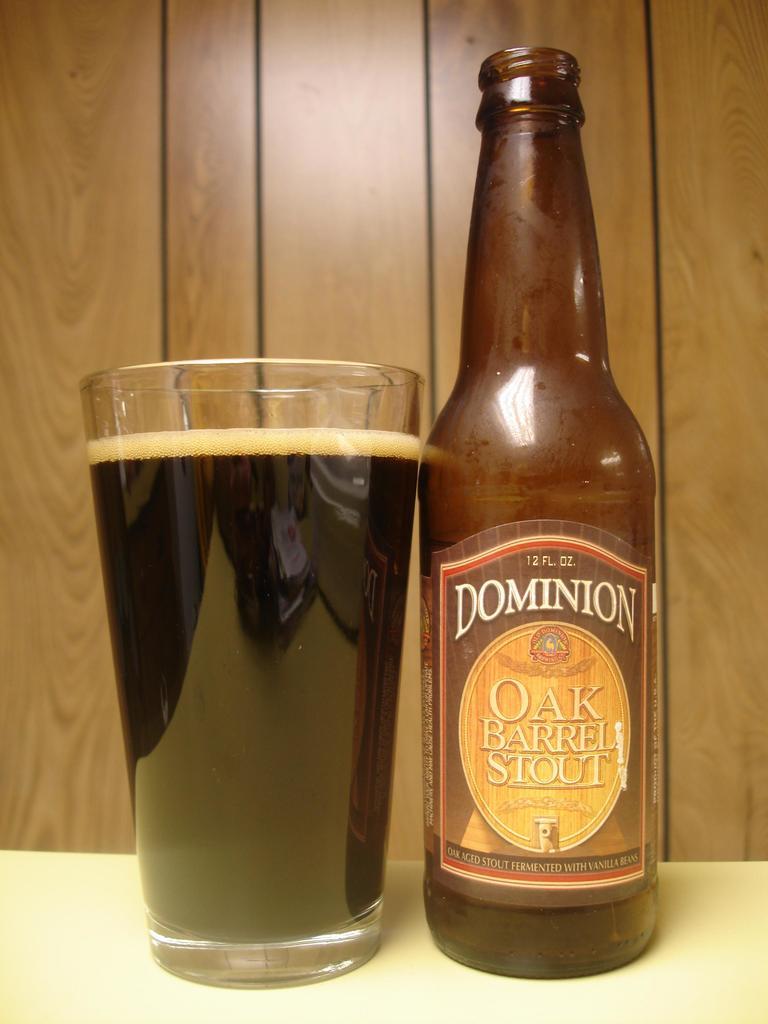What drink is this?
Make the answer very short. Oak barrel stout. What is the brand of this drink?
Offer a terse response. Dominion. 